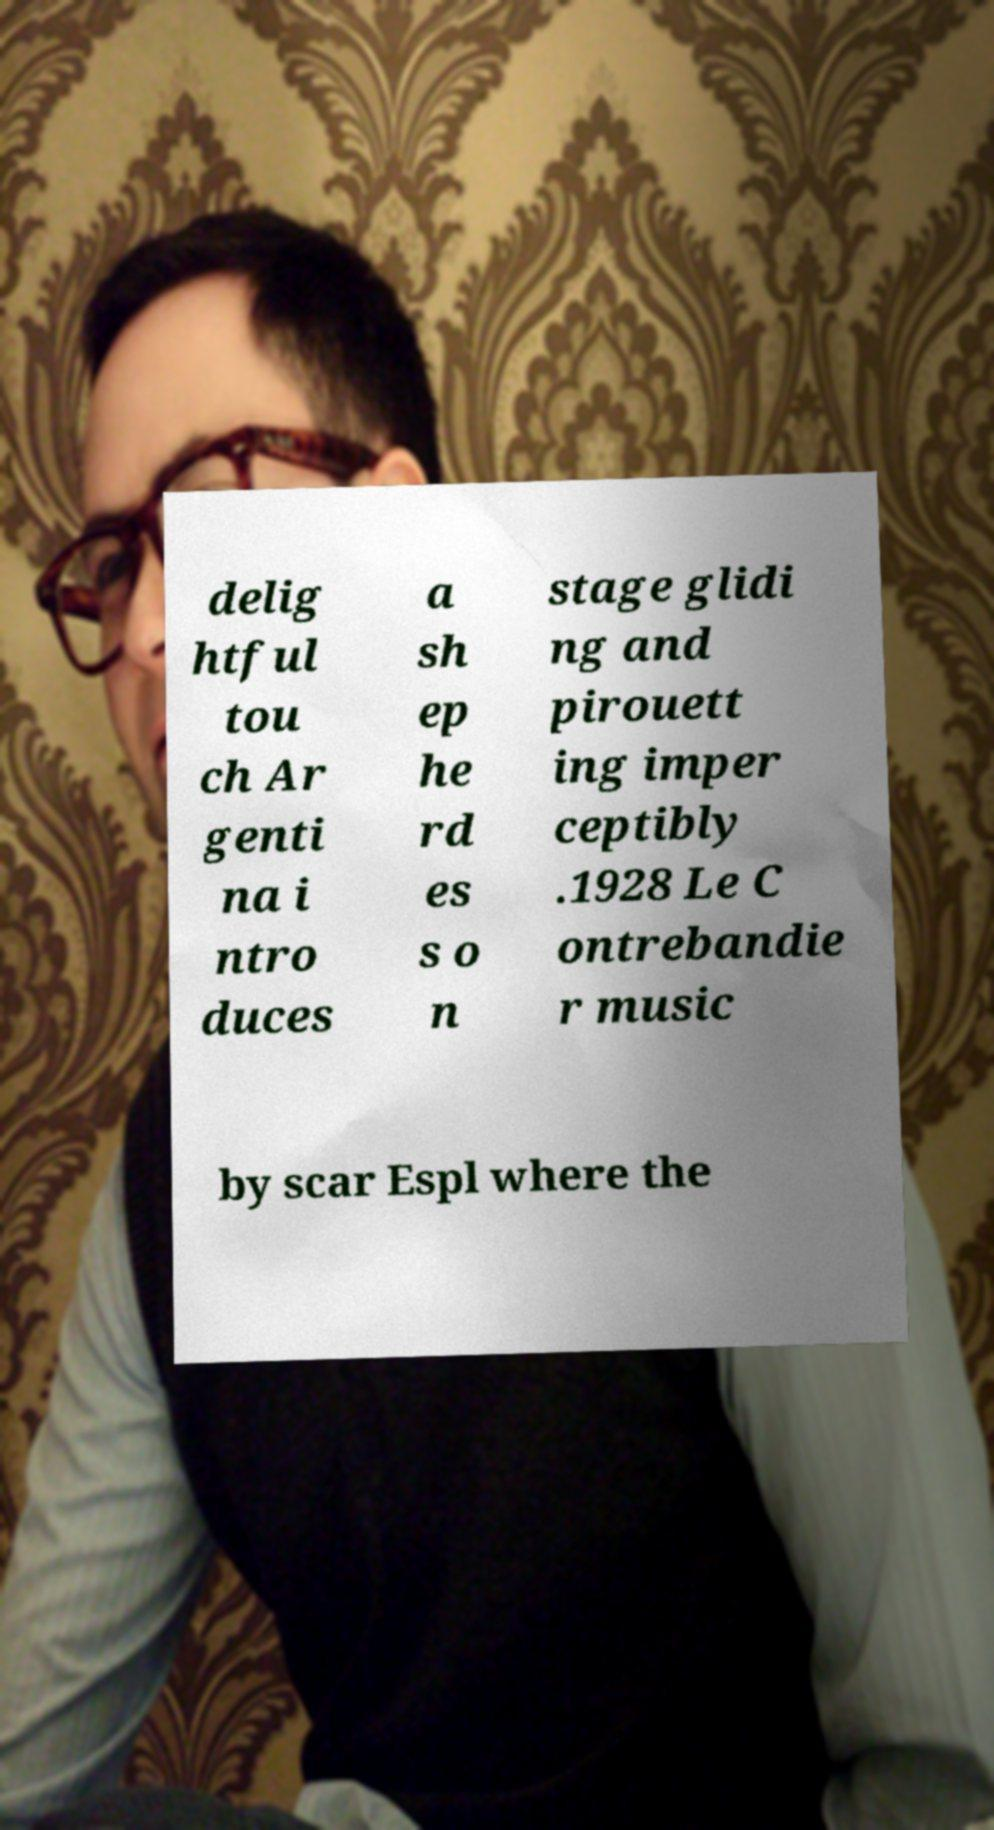Please read and relay the text visible in this image. What does it say? delig htful tou ch Ar genti na i ntro duces a sh ep he rd es s o n stage glidi ng and pirouett ing imper ceptibly .1928 Le C ontrebandie r music by scar Espl where the 